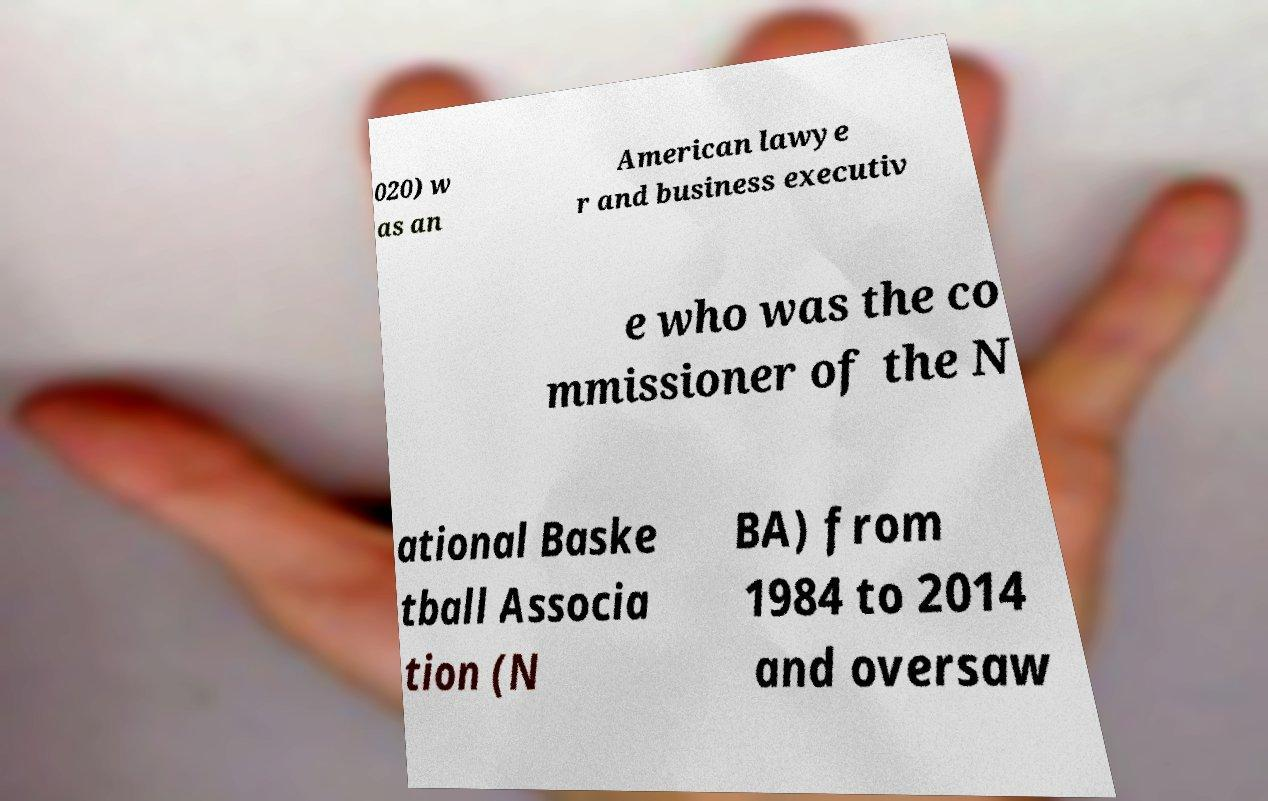What messages or text are displayed in this image? I need them in a readable, typed format. 020) w as an American lawye r and business executiv e who was the co mmissioner of the N ational Baske tball Associa tion (N BA) from 1984 to 2014 and oversaw 